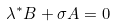<formula> <loc_0><loc_0><loc_500><loc_500>\lambda ^ { * } B + \sigma A = 0</formula> 